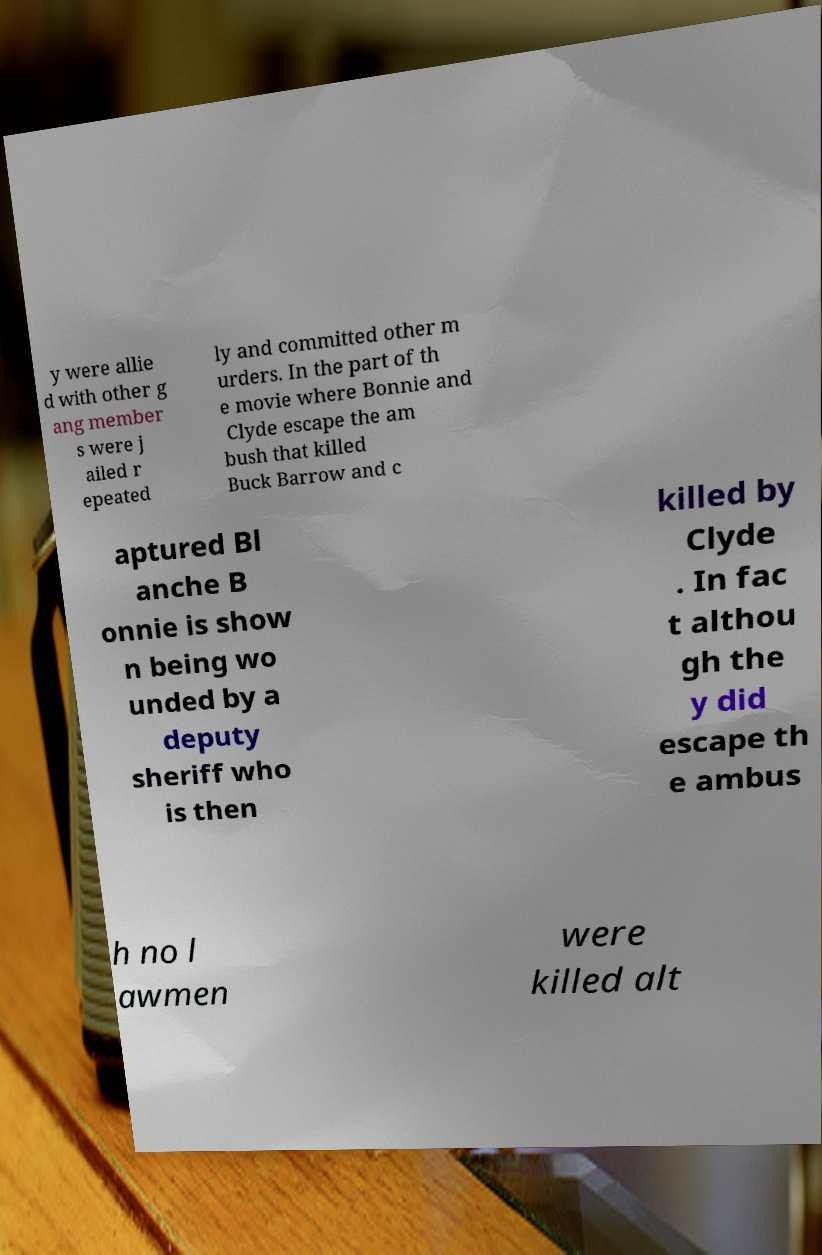Please identify and transcribe the text found in this image. y were allie d with other g ang member s were j ailed r epeated ly and committed other m urders. In the part of th e movie where Bonnie and Clyde escape the am bush that killed Buck Barrow and c aptured Bl anche B onnie is show n being wo unded by a deputy sheriff who is then killed by Clyde . In fac t althou gh the y did escape th e ambus h no l awmen were killed alt 